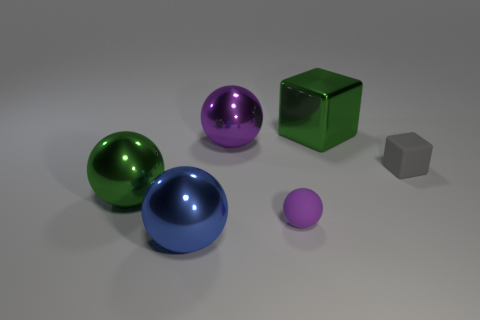Subtract all yellow spheres. Subtract all green cubes. How many spheres are left? 4 Add 3 gray matte things. How many objects exist? 9 Subtract all blocks. How many objects are left? 4 Subtract all large blue things. Subtract all balls. How many objects are left? 1 Add 3 big blue things. How many big blue things are left? 4 Add 4 gray rubber spheres. How many gray rubber spheres exist? 4 Subtract 0 green cylinders. How many objects are left? 6 